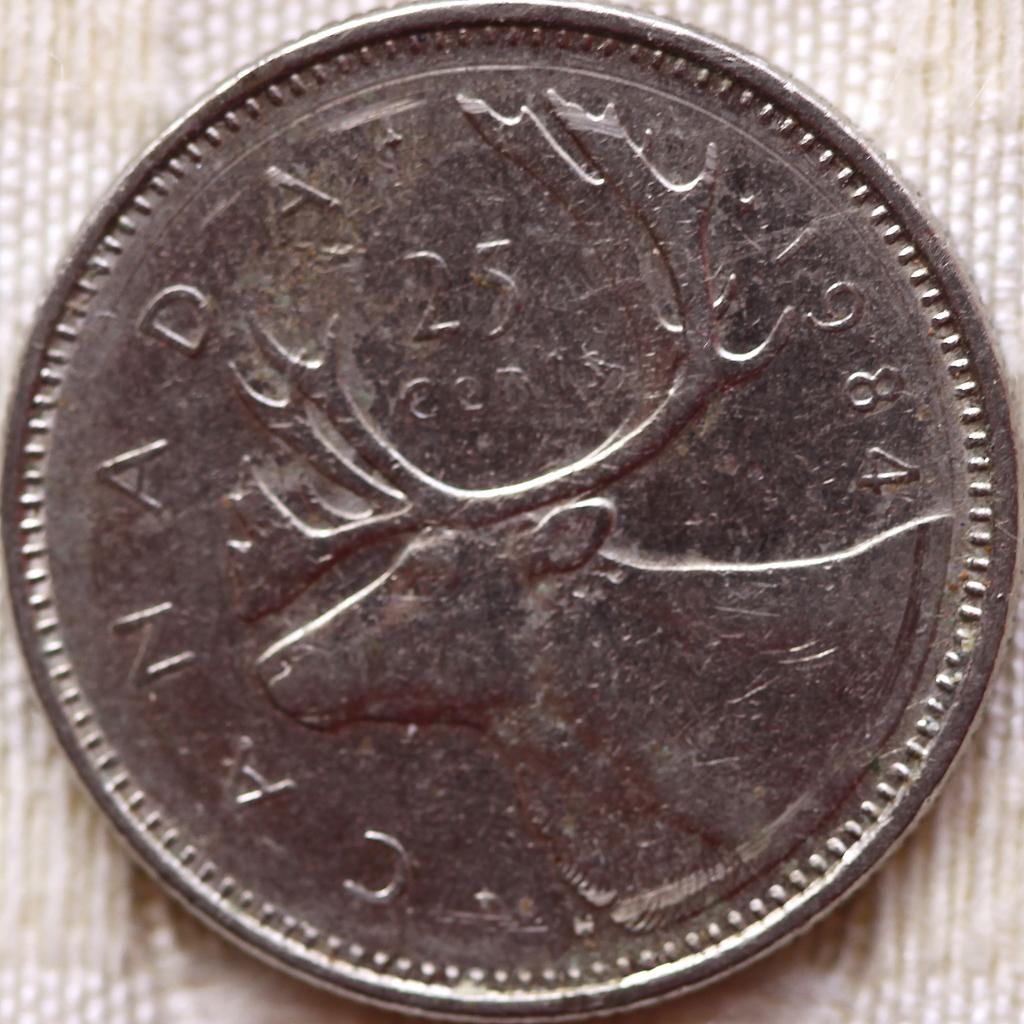<image>
Render a clear and concise summary of the photo. a  silver canadian quarter with a deer on it 